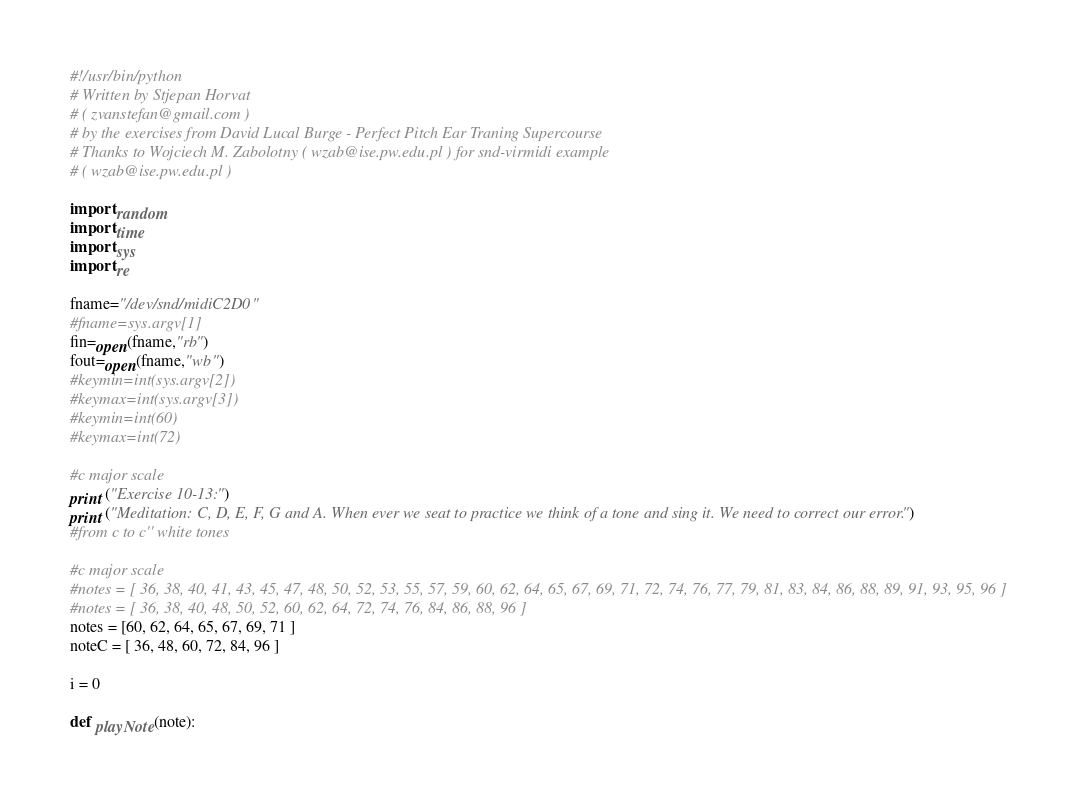<code> <loc_0><loc_0><loc_500><loc_500><_Python_>#!/usr/bin/python
# Written by Stjepan Horvat
# ( zvanstefan@gmail.com )
# by the exercises from David Lucal Burge - Perfect Pitch Ear Traning Supercourse
# Thanks to Wojciech M. Zabolotny ( wzab@ise.pw.edu.pl ) for snd-virmidi example
# ( wzab@ise.pw.edu.pl )

import random
import time
import sys
import re

fname="/dev/snd/midiC2D0"
#fname=sys.argv[1]
fin=open(fname,"rb")
fout=open(fname,"wb")
#keymin=int(sys.argv[2])
#keymax=int(sys.argv[3])
#keymin=int(60)
#keymax=int(72)

#c major scale
print ("Exercise 10-13:")
print ("Meditation: C, D, E, F, G and A. When ever we seat to practice we think of a tone and sing it. We need to correct our error.")
#from c to c'' white tones

#c major scale
#notes = [ 36, 38, 40, 41, 43, 45, 47, 48, 50, 52, 53, 55, 57, 59, 60, 62, 64, 65, 67, 69, 71, 72, 74, 76, 77, 79, 81, 83, 84, 86, 88, 89, 91, 93, 95, 96 ]
#notes = [ 36, 38, 40, 48, 50, 52, 60, 62, 64, 72, 74, 76, 84, 86, 88, 96 ]
notes = [60, 62, 64, 65, 67, 69, 71 ]
noteC = [ 36, 48, 60, 72, 84, 96 ]

i = 0

def playNote(note):</code> 